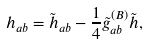Convert formula to latex. <formula><loc_0><loc_0><loc_500><loc_500>h _ { a b } = \tilde { h } _ { a b } - \frac { 1 } { 4 } \tilde { g } ^ { ( B ) } _ { a b } \tilde { h } ,</formula> 